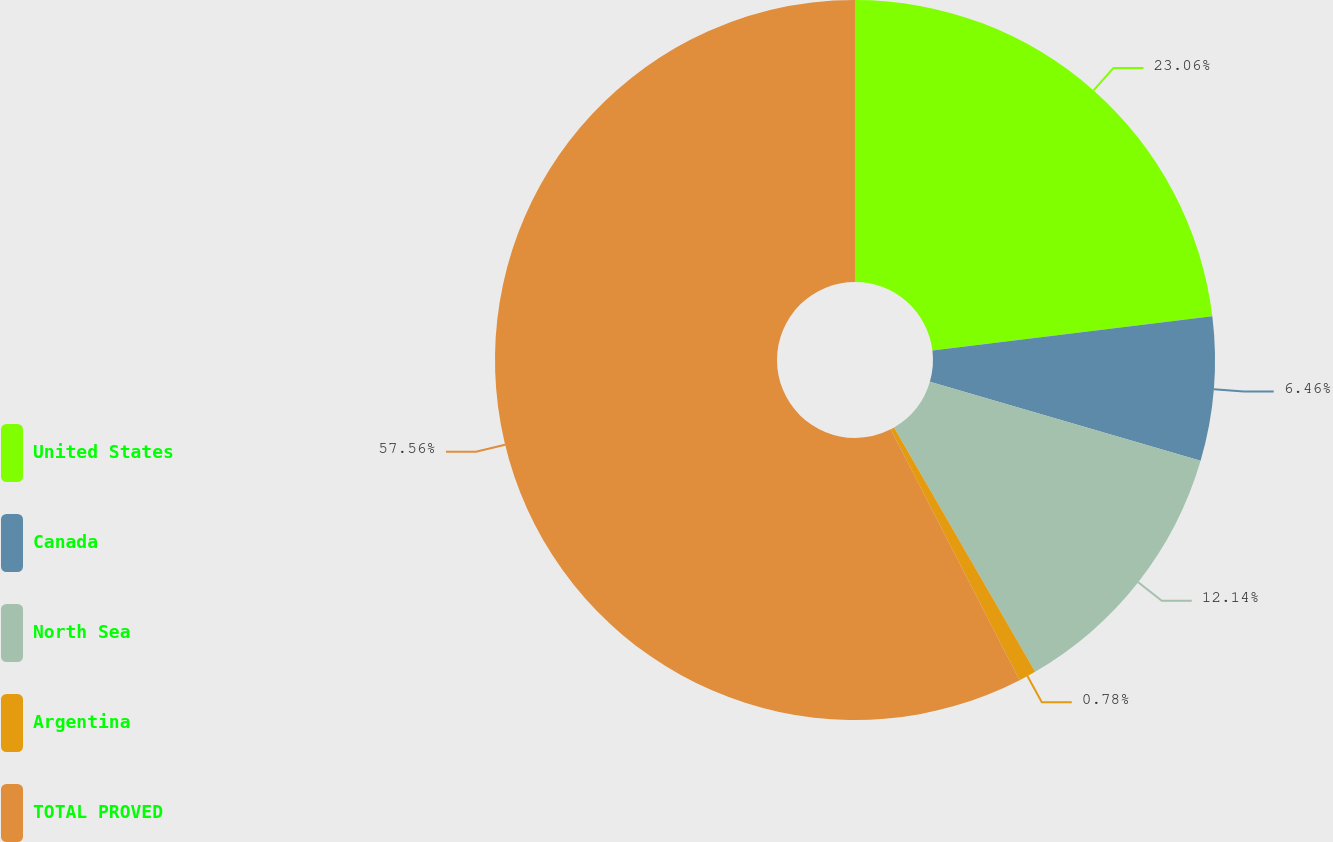Convert chart to OTSL. <chart><loc_0><loc_0><loc_500><loc_500><pie_chart><fcel>United States<fcel>Canada<fcel>North Sea<fcel>Argentina<fcel>TOTAL PROVED<nl><fcel>23.06%<fcel>6.46%<fcel>12.14%<fcel>0.78%<fcel>57.56%<nl></chart> 